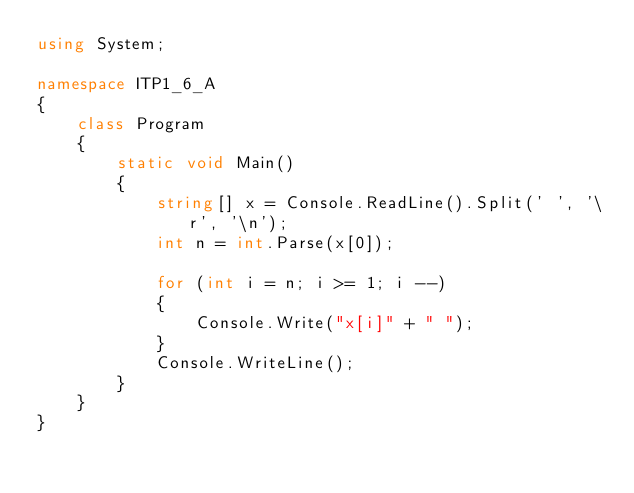<code> <loc_0><loc_0><loc_500><loc_500><_C#_>using System;

namespace ITP1_6_A
{
    class Program
    {
        static void Main()
        {
            string[] x = Console.ReadLine().Split(' ', '\r', '\n');
            int n = int.Parse(x[0]);
            
            for (int i = n; i >= 1; i --)
            {
                Console.Write("x[i]" + " ");
            }
            Console.WriteLine();
        }
    }
}
</code> 